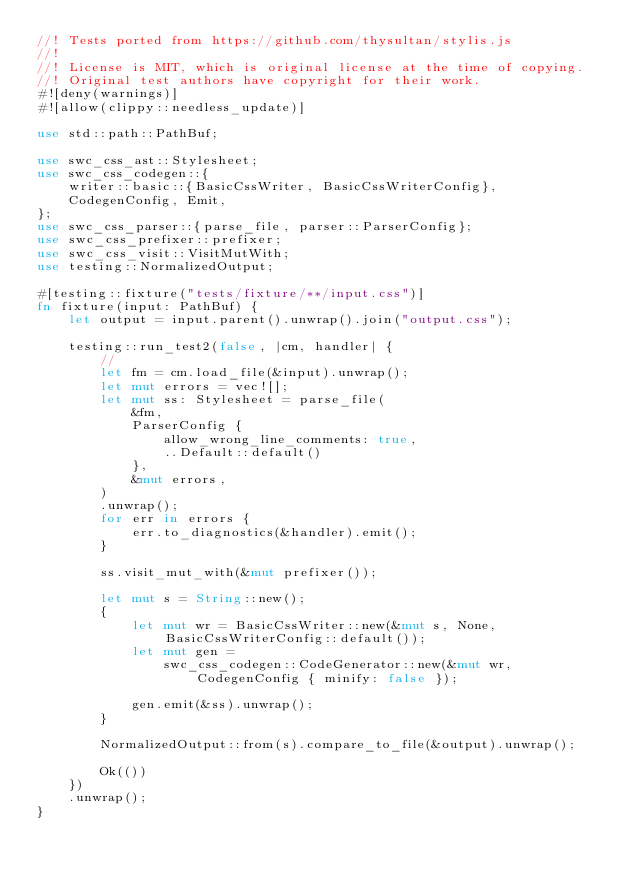<code> <loc_0><loc_0><loc_500><loc_500><_Rust_>//! Tests ported from https://github.com/thysultan/stylis.js
//!
//! License is MIT, which is original license at the time of copying.
//! Original test authors have copyright for their work.
#![deny(warnings)]
#![allow(clippy::needless_update)]

use std::path::PathBuf;

use swc_css_ast::Stylesheet;
use swc_css_codegen::{
    writer::basic::{BasicCssWriter, BasicCssWriterConfig},
    CodegenConfig, Emit,
};
use swc_css_parser::{parse_file, parser::ParserConfig};
use swc_css_prefixer::prefixer;
use swc_css_visit::VisitMutWith;
use testing::NormalizedOutput;

#[testing::fixture("tests/fixture/**/input.css")]
fn fixture(input: PathBuf) {
    let output = input.parent().unwrap().join("output.css");

    testing::run_test2(false, |cm, handler| {
        //
        let fm = cm.load_file(&input).unwrap();
        let mut errors = vec![];
        let mut ss: Stylesheet = parse_file(
            &fm,
            ParserConfig {
                allow_wrong_line_comments: true,
                ..Default::default()
            },
            &mut errors,
        )
        .unwrap();
        for err in errors {
            err.to_diagnostics(&handler).emit();
        }

        ss.visit_mut_with(&mut prefixer());

        let mut s = String::new();
        {
            let mut wr = BasicCssWriter::new(&mut s, None, BasicCssWriterConfig::default());
            let mut gen =
                swc_css_codegen::CodeGenerator::new(&mut wr, CodegenConfig { minify: false });

            gen.emit(&ss).unwrap();
        }

        NormalizedOutput::from(s).compare_to_file(&output).unwrap();

        Ok(())
    })
    .unwrap();
}
</code> 